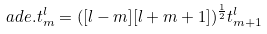<formula> <loc_0><loc_0><loc_500><loc_500>a d e . t _ { m } ^ { l } = ( [ l - m ] [ l + m + 1 ] ) ^ { \frac { 1 } { 2 } } t _ { m + 1 } ^ { l }</formula> 